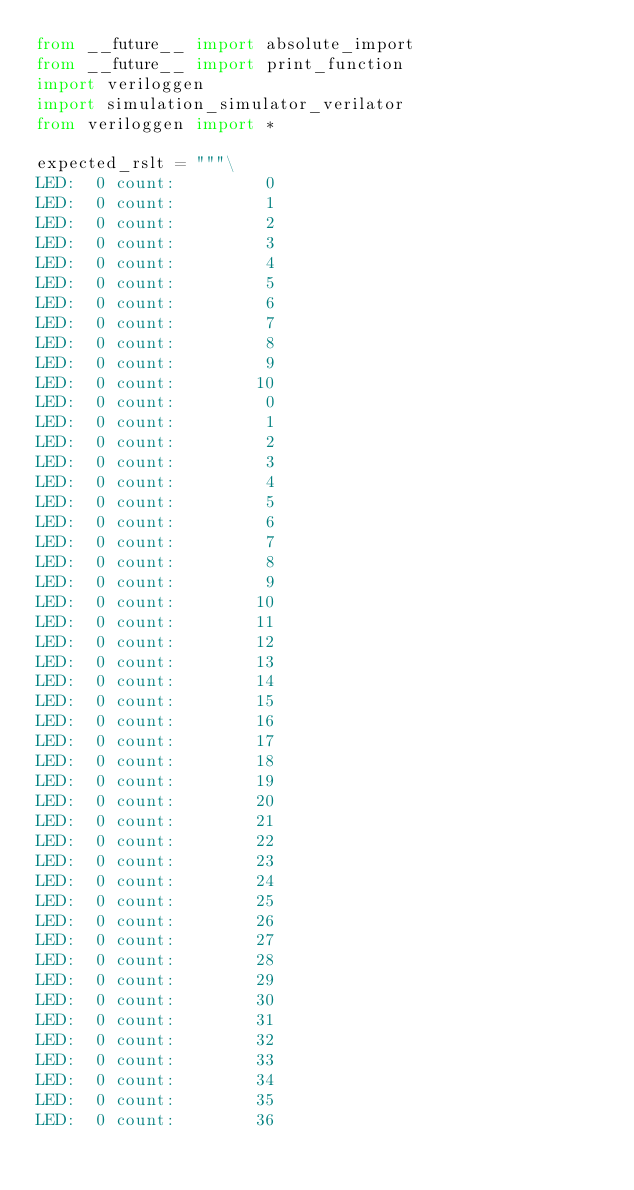<code> <loc_0><loc_0><loc_500><loc_500><_Python_>from __future__ import absolute_import
from __future__ import print_function
import veriloggen
import simulation_simulator_verilator
from veriloggen import *

expected_rslt = """\
LED:  0 count:         0
LED:  0 count:         1
LED:  0 count:         2
LED:  0 count:         3
LED:  0 count:         4
LED:  0 count:         5
LED:  0 count:         6
LED:  0 count:         7
LED:  0 count:         8
LED:  0 count:         9
LED:  0 count:        10
LED:  0 count:         0
LED:  0 count:         1
LED:  0 count:         2
LED:  0 count:         3
LED:  0 count:         4
LED:  0 count:         5
LED:  0 count:         6
LED:  0 count:         7
LED:  0 count:         8
LED:  0 count:         9
LED:  0 count:        10
LED:  0 count:        11
LED:  0 count:        12
LED:  0 count:        13
LED:  0 count:        14
LED:  0 count:        15
LED:  0 count:        16
LED:  0 count:        17
LED:  0 count:        18
LED:  0 count:        19
LED:  0 count:        20
LED:  0 count:        21
LED:  0 count:        22
LED:  0 count:        23
LED:  0 count:        24
LED:  0 count:        25
LED:  0 count:        26
LED:  0 count:        27
LED:  0 count:        28
LED:  0 count:        29
LED:  0 count:        30
LED:  0 count:        31
LED:  0 count:        32
LED:  0 count:        33
LED:  0 count:        34
LED:  0 count:        35
LED:  0 count:        36</code> 